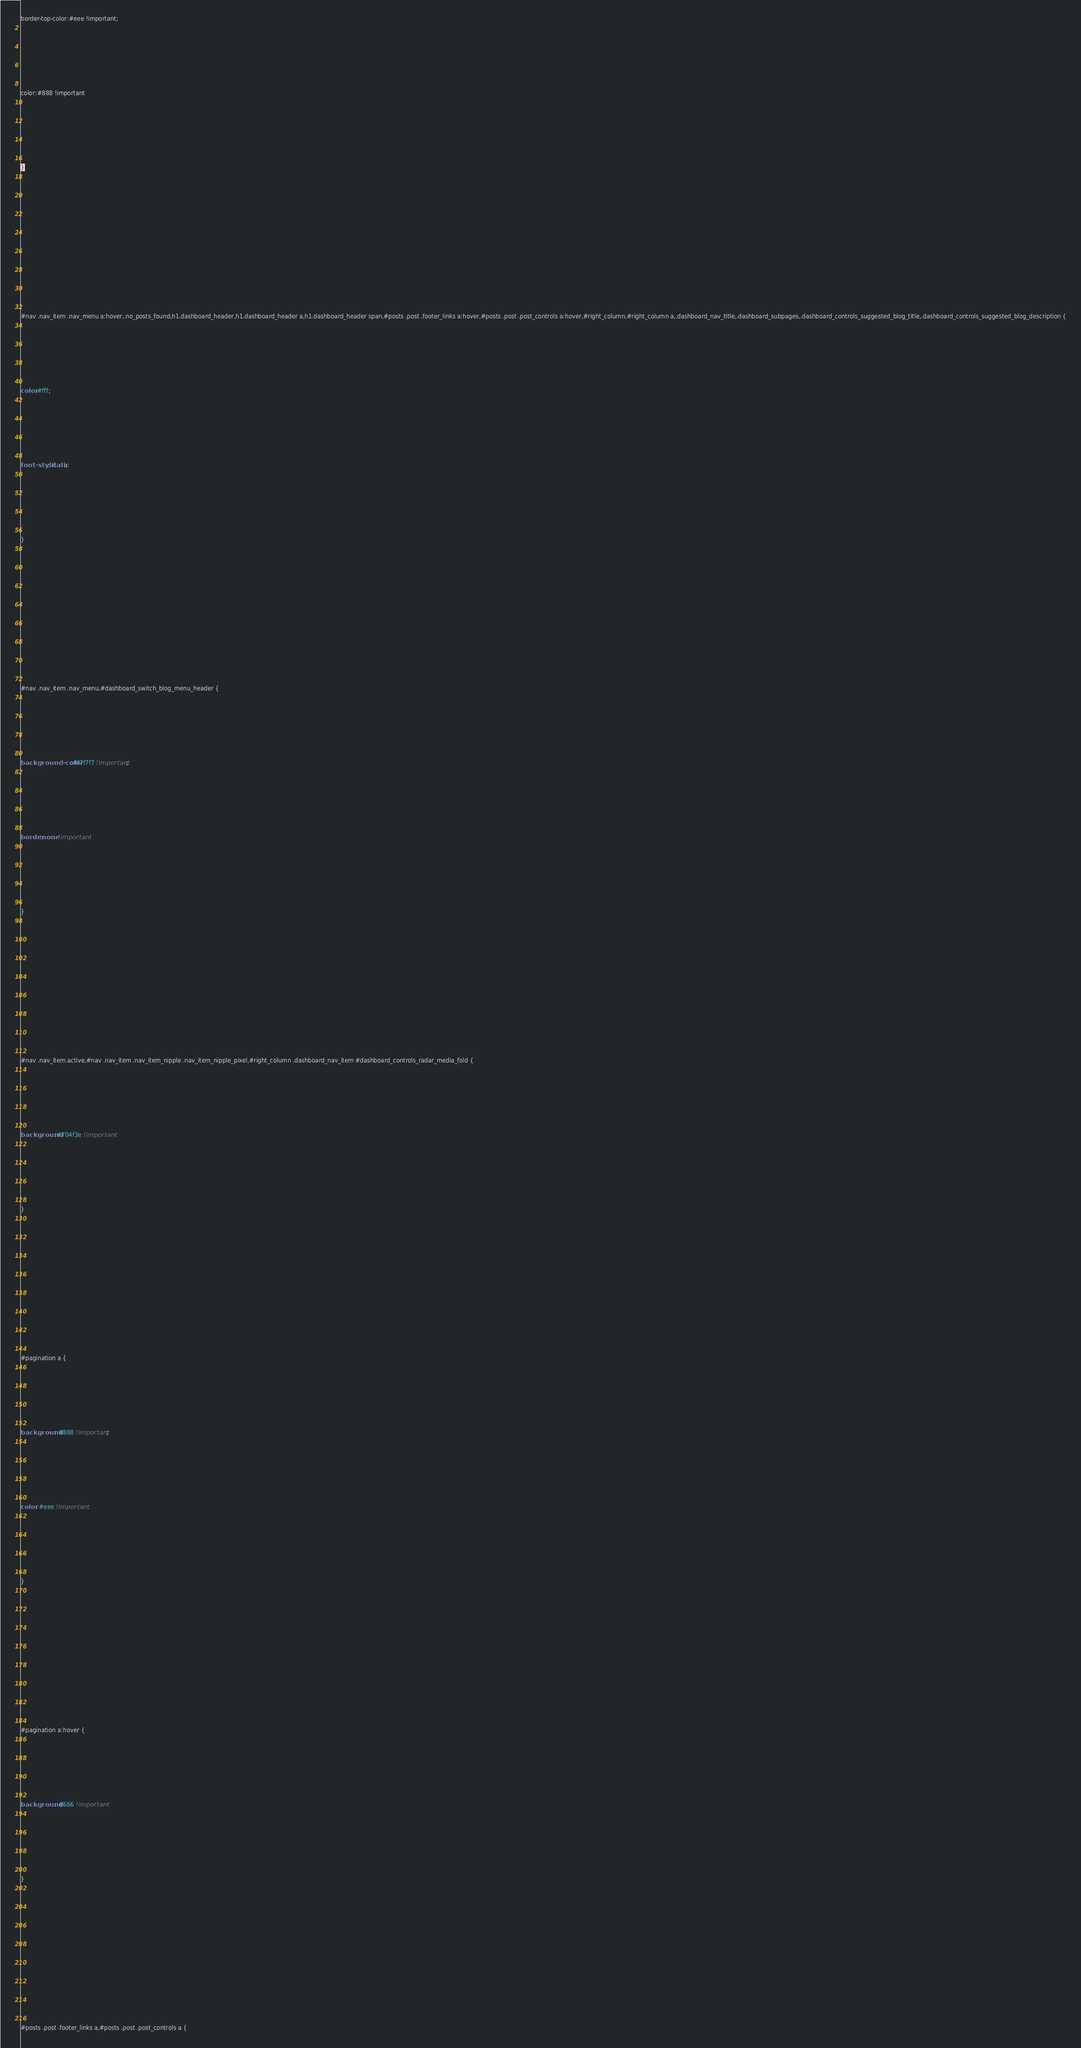Convert code to text. <code><loc_0><loc_0><loc_500><loc_500><_CSS_>




border-top-color:#eee !important;







color:#888 !important







}















#nav .nav_item .nav_menu a:hover,.no_posts_found,h1.dashboard_header,h1.dashboard_header a,h1.dashboard_header span,#posts .post .footer_links a:hover,#posts .post .post_controls a:hover,#right_column,#right_column a,.dashboard_nav_title,.dashboard_subpages,.dashboard_controls_suggested_blog_title,.dashboard_controls_suggested_blog_description {







color:#fff;







font-style: italic;







}















#nav .nav_item .nav_menu,#dashboard_switch_blog_menu_header {







background-color:#f7f7f7 !important;







border:none !important







}















#nav .nav_item.active,#nav .nav_item .nav_item_nipple .nav_item_nipple_pixel,#right_column .dashboard_nav_item #dashboard_controls_radar_media_fold {







background:#704f3e !important







}















#pagination a {







background: #888 !important;







color: #eee !important







}















#pagination a:hover {







background: #666 !important







}















#posts .post .footer_links a,#posts .post .post_controls a {
</code> 